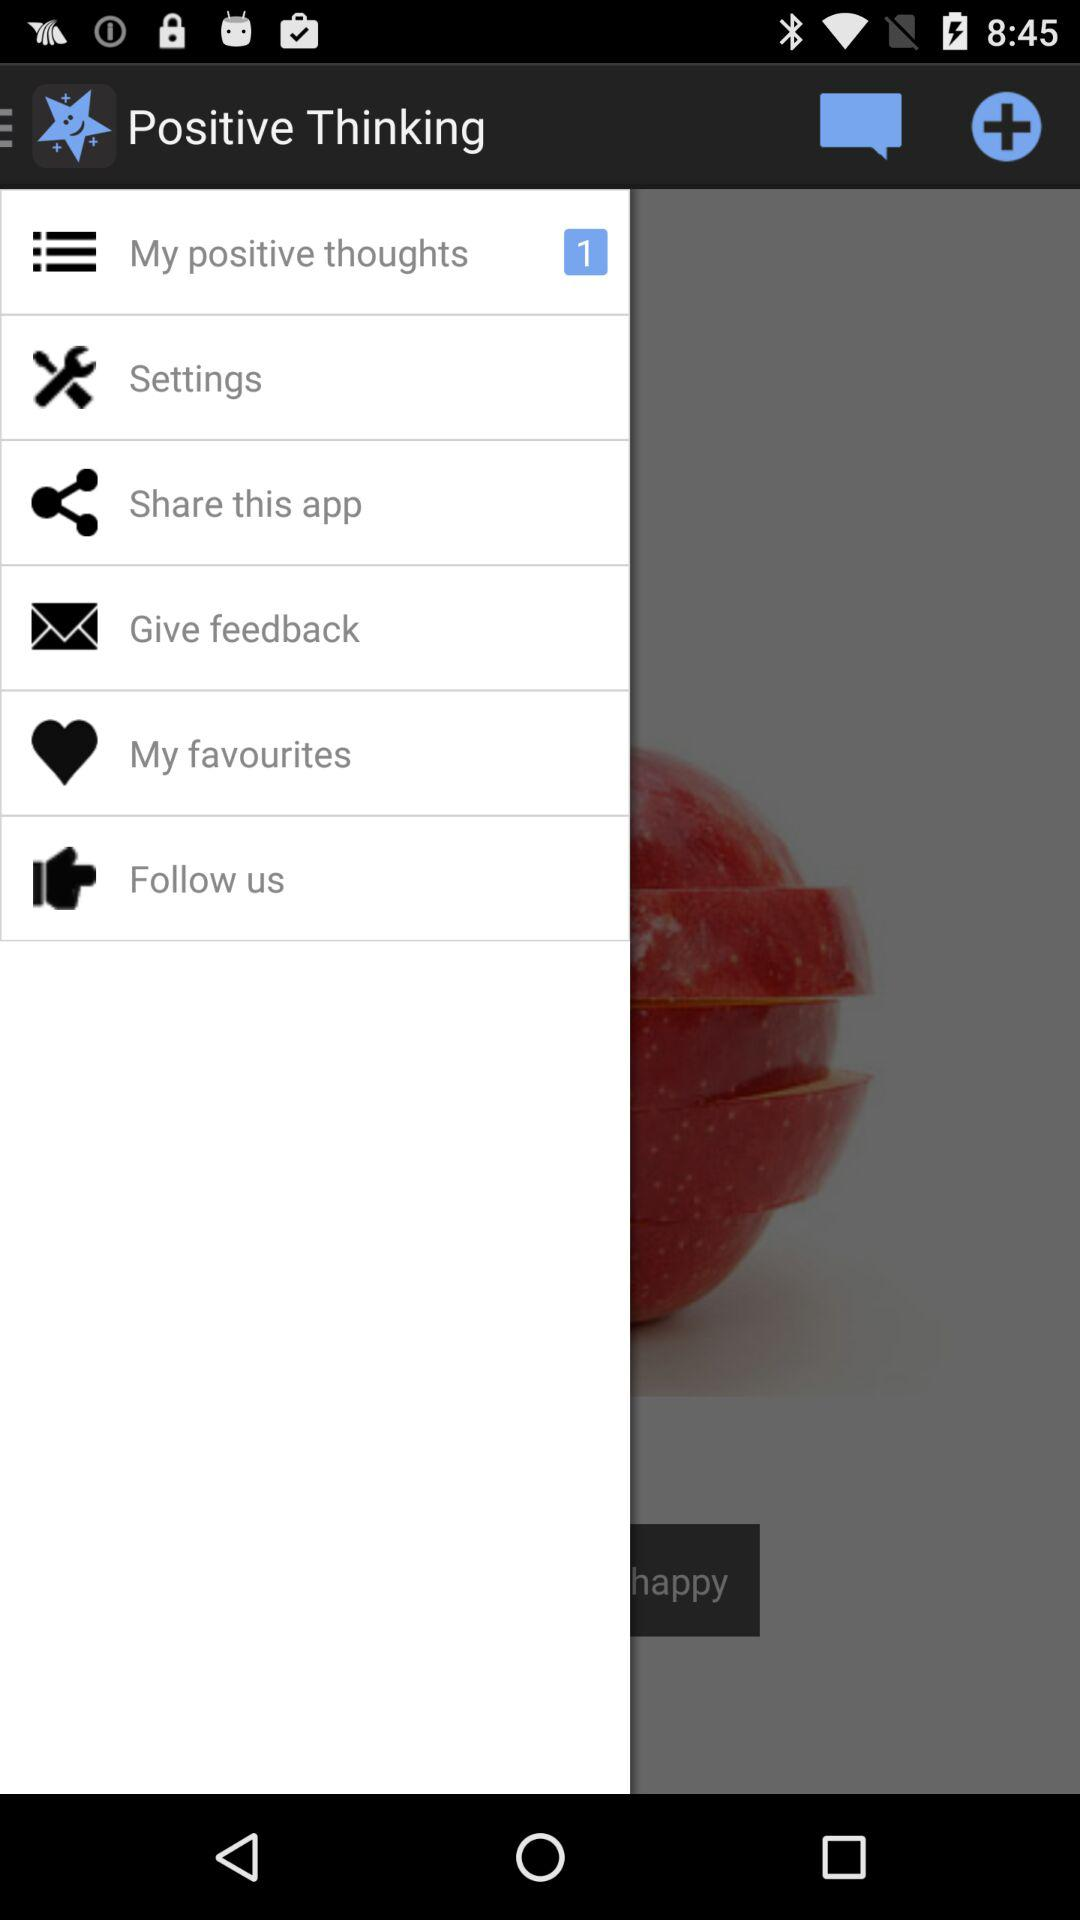How many unread notifications are there for "My positive thoughts"? There is 1 unread notification. 